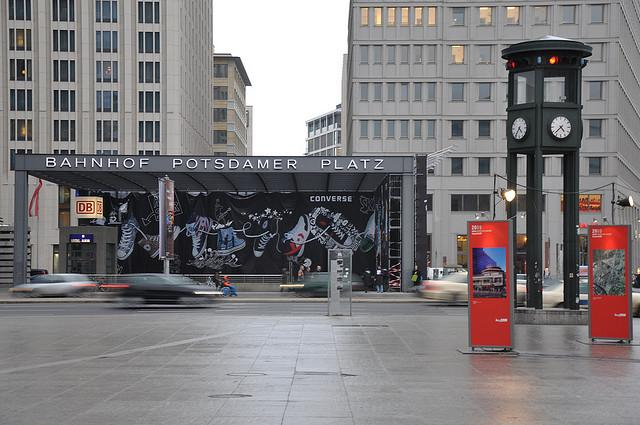One will come here if one wants to do what? Please explain your reasoning. take train. There are signs indicating this is a stop for public transportation. 